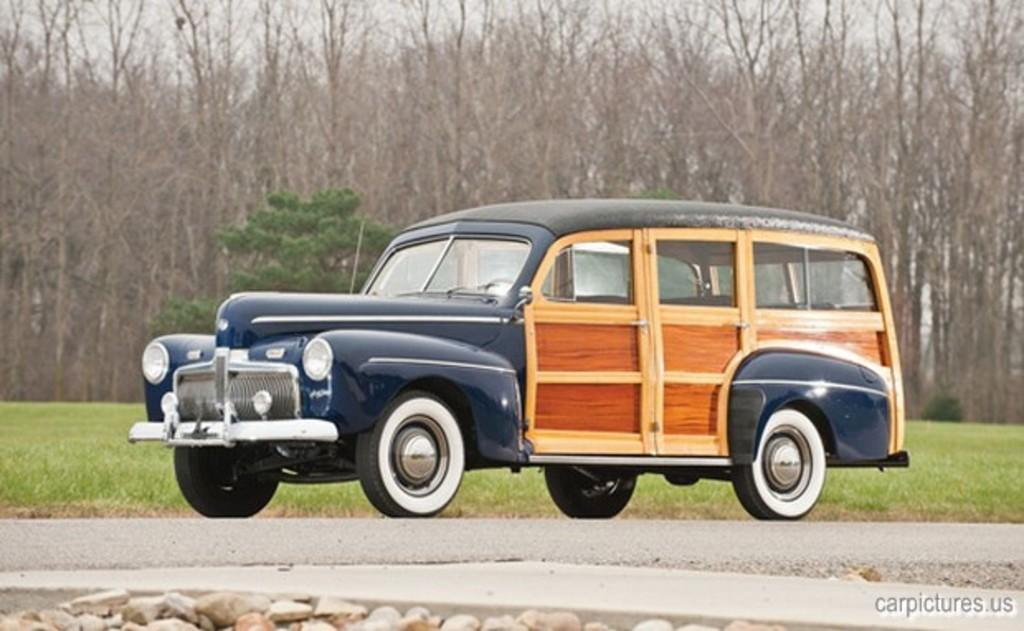What is parked on the road in the image? There is a car parked on the road in the image. What type of surface is the car parked on? The ground is covered with grass. What can be seen in the background of the image? There are trees visible in the image. What type of needle is being used to smash the car in the image? There is no needle or smashing action present in the image; it shows a parked car on a grassy surface with trees in the background. 